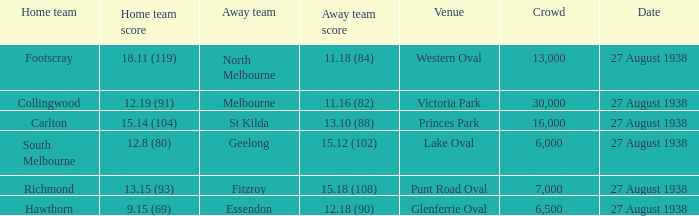Western oval is home to which team? Footscray. 